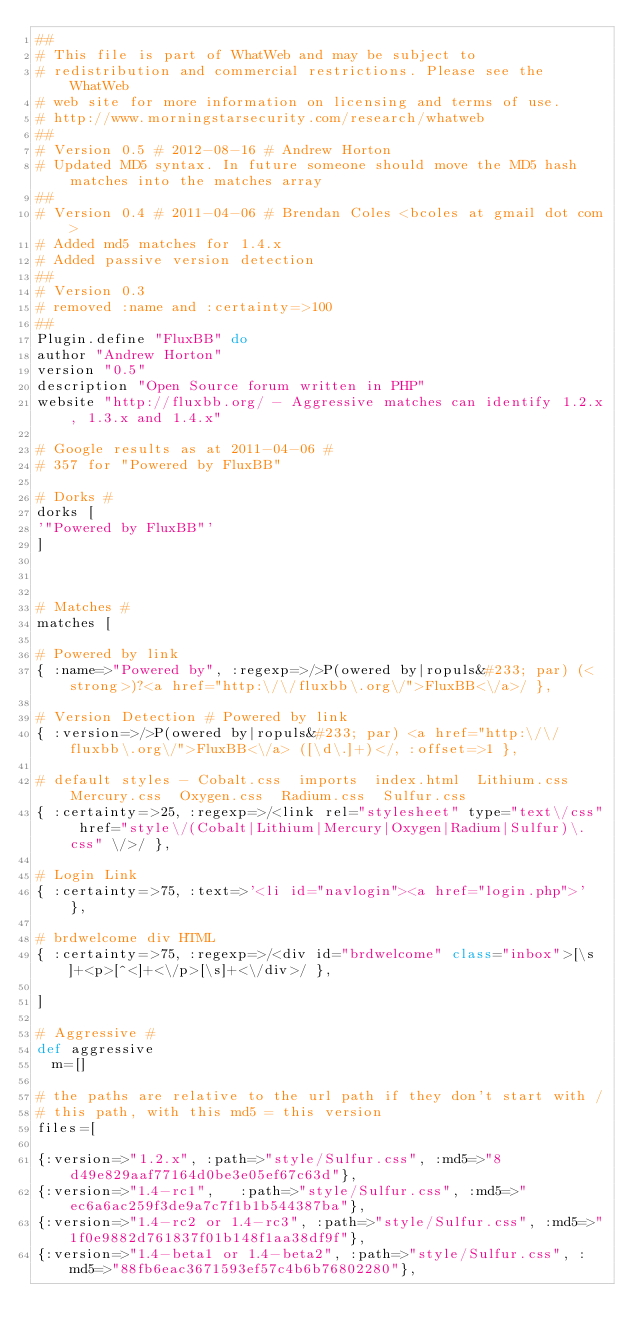<code> <loc_0><loc_0><loc_500><loc_500><_Ruby_>##
# This file is part of WhatWeb and may be subject to
# redistribution and commercial restrictions. Please see the WhatWeb
# web site for more information on licensing and terms of use.
# http://www.morningstarsecurity.com/research/whatweb
##
# Version 0.5 # 2012-08-16 # Andrew Horton
# Updated MD5 syntax. In future someone should move the MD5 hash matches into the matches array
##
# Version 0.4 # 2011-04-06 # Brendan Coles <bcoles at gmail dot com>
# Added md5 matches for 1.4.x
# Added passive version detection
##
# Version 0.3
# removed :name and :certainty=>100
##
Plugin.define "FluxBB" do
author "Andrew Horton"
version "0.5"
description "Open Source forum written in PHP"
website "http://fluxbb.org/ - Aggressive matches can identify 1.2.x, 1.3.x and 1.4.x"

# Google results as at 2011-04-06 #
# 357 for "Powered by FluxBB"

# Dorks #
dorks [
'"Powered by FluxBB"'
]



# Matches #
matches [

# Powered by link
{ :name=>"Powered by", :regexp=>/>P(owered by|ropuls&#233; par) (<strong>)?<a href="http:\/\/fluxbb\.org\/">FluxBB<\/a>/ },

# Version Detection # Powered by link
{ :version=>/>P(owered by|ropuls&#233; par) <a href="http:\/\/fluxbb\.org\/">FluxBB<\/a> ([\d\.]+)</, :offset=>1 },

# default styles - Cobalt.css  imports  index.html  Lithium.css  Mercury.css  Oxygen.css  Radium.css  Sulfur.css
{ :certainty=>25, :regexp=>/<link rel="stylesheet" type="text\/css" href="style\/(Cobalt|Lithium|Mercury|Oxygen|Radium|Sulfur)\.css" \/>/ },

# Login Link
{ :certainty=>75, :text=>'<li id="navlogin"><a href="login.php">' },

# brdwelcome div HTML
{ :certainty=>75, :regexp=>/<div id="brdwelcome" class="inbox">[\s]+<p>[^<]+<\/p>[\s]+<\/div>/ },

]

# Aggressive #
def aggressive
	m=[]

# the paths are relative to the url path if they don't start with /
# this path, with this md5 = this version
files=[

{:version=>"1.2.x",	:path=>"style/Sulfur.css", :md5=>"8d49e829aaf77164d0be3e05ef67c63d"},
{:version=>"1.4-rc1",   :path=>"style/Sulfur.css", :md5=>"ec6a6ac259f3de9a7c7f1b1b544387ba"},
{:version=>"1.4-rc2 or 1.4-rc3", :path=>"style/Sulfur.css", :md5=>"1f0e9882d761837f01b148f1aa38df9f"},
{:version=>"1.4-beta1 or 1.4-beta2", :path=>"style/Sulfur.css", :md5=>"88fb6eac3671593ef57c4b6b76802280"},</code> 